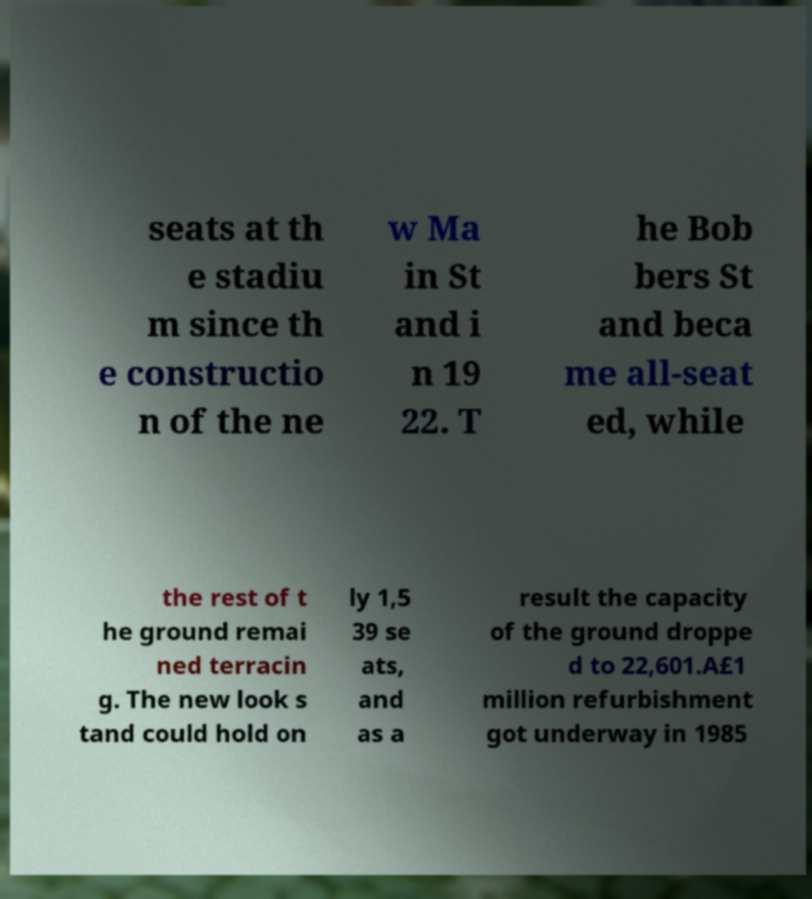I need the written content from this picture converted into text. Can you do that? seats at th e stadiu m since th e constructio n of the ne w Ma in St and i n 19 22. T he Bob bers St and beca me all-seat ed, while the rest of t he ground remai ned terracin g. The new look s tand could hold on ly 1,5 39 se ats, and as a result the capacity of the ground droppe d to 22,601.A£1 million refurbishment got underway in 1985 